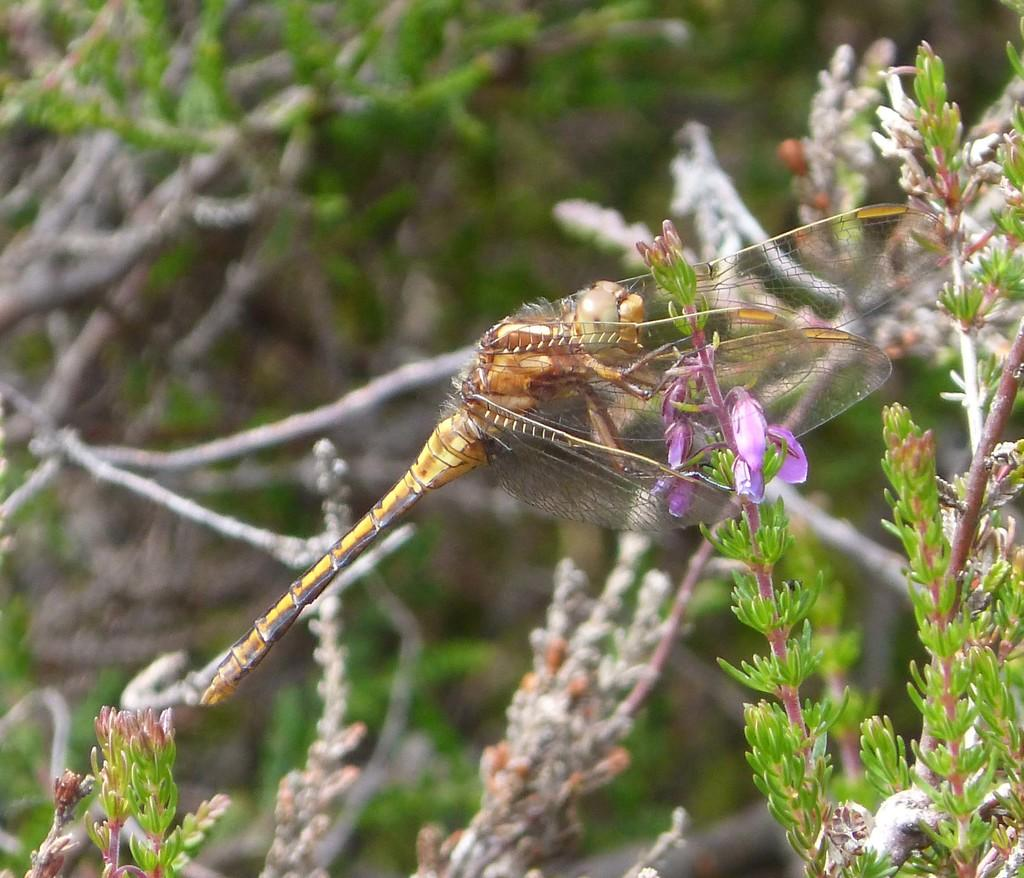What type of creature is in the image? There is an insect in the image. Can you describe the color of the insect? The insect is brown and cream colored. Where is the insect located in the image? The insect is on a plant. What is the color of the plant? The plant is green. What type of badge can be seen hanging from the airport in the image? There is no airport or badge present in the image; it features an insect on a plant. 